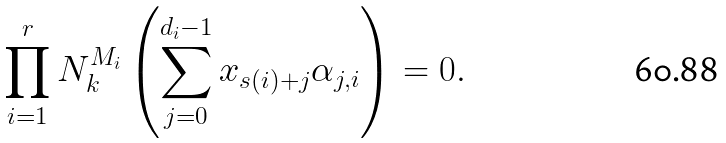<formula> <loc_0><loc_0><loc_500><loc_500>\prod _ { i = 1 } ^ { r } N ^ { M _ { i } } _ { k } \left ( \sum _ { j = 0 } ^ { d _ { i } - 1 } x _ { s ( i ) + j } \alpha _ { j , i } \right ) = 0 .</formula> 